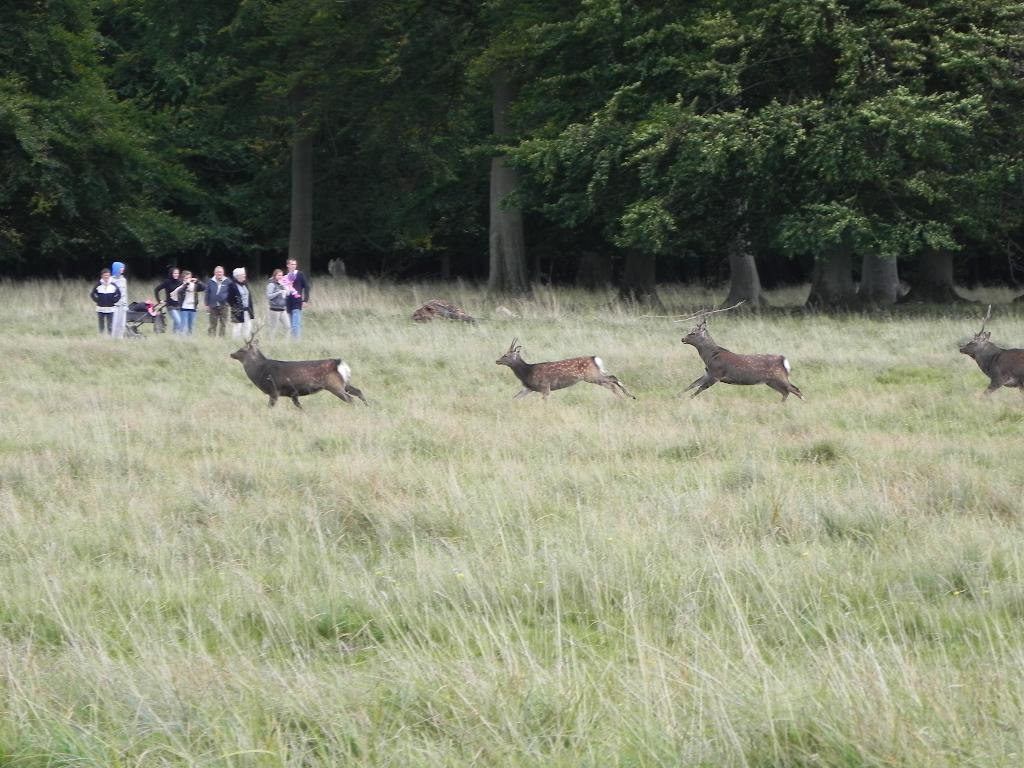What are the animals in the image doing? The animals are running in the image. What is the environment like where the animals are running? The animals are running in between the grass. Can you describe the people in the image? There is a group of people behind the animals. What can be seen in the background of the image? There are huge trees in the background of the image. What type of zinc is being used to create the rain in the image? There is no rain present in the image, and therefore no zinc is being used. Can you describe the sofa that the animals are sitting on in the image? There is no sofa present in the image; the animals are running in between the grass. 